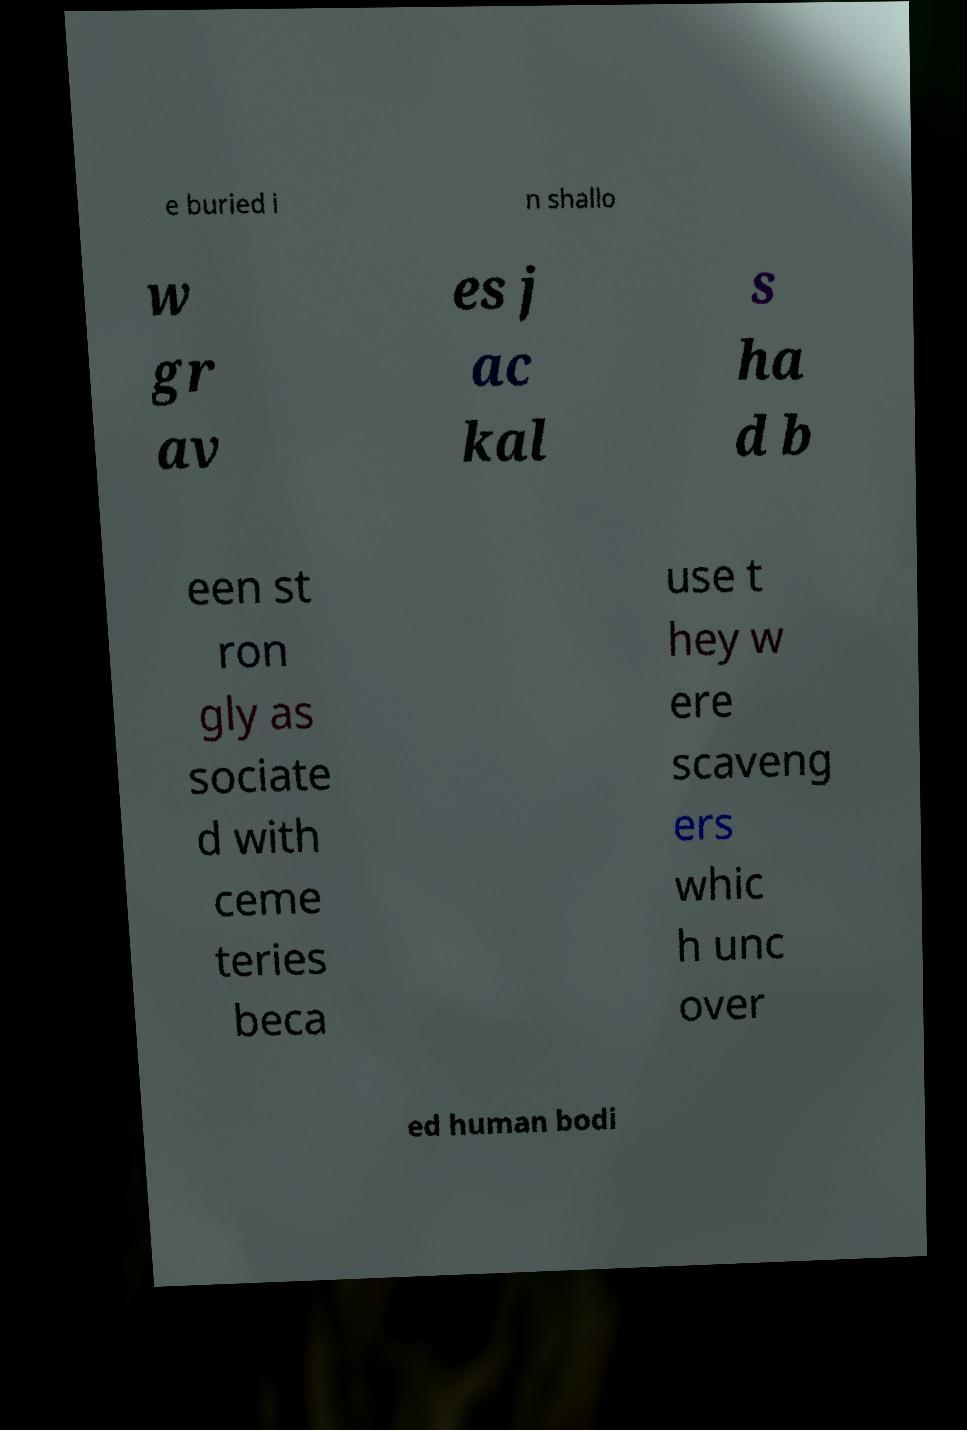What messages or text are displayed in this image? I need them in a readable, typed format. e buried i n shallo w gr av es j ac kal s ha d b een st ron gly as sociate d with ceme teries beca use t hey w ere scaveng ers whic h unc over ed human bodi 